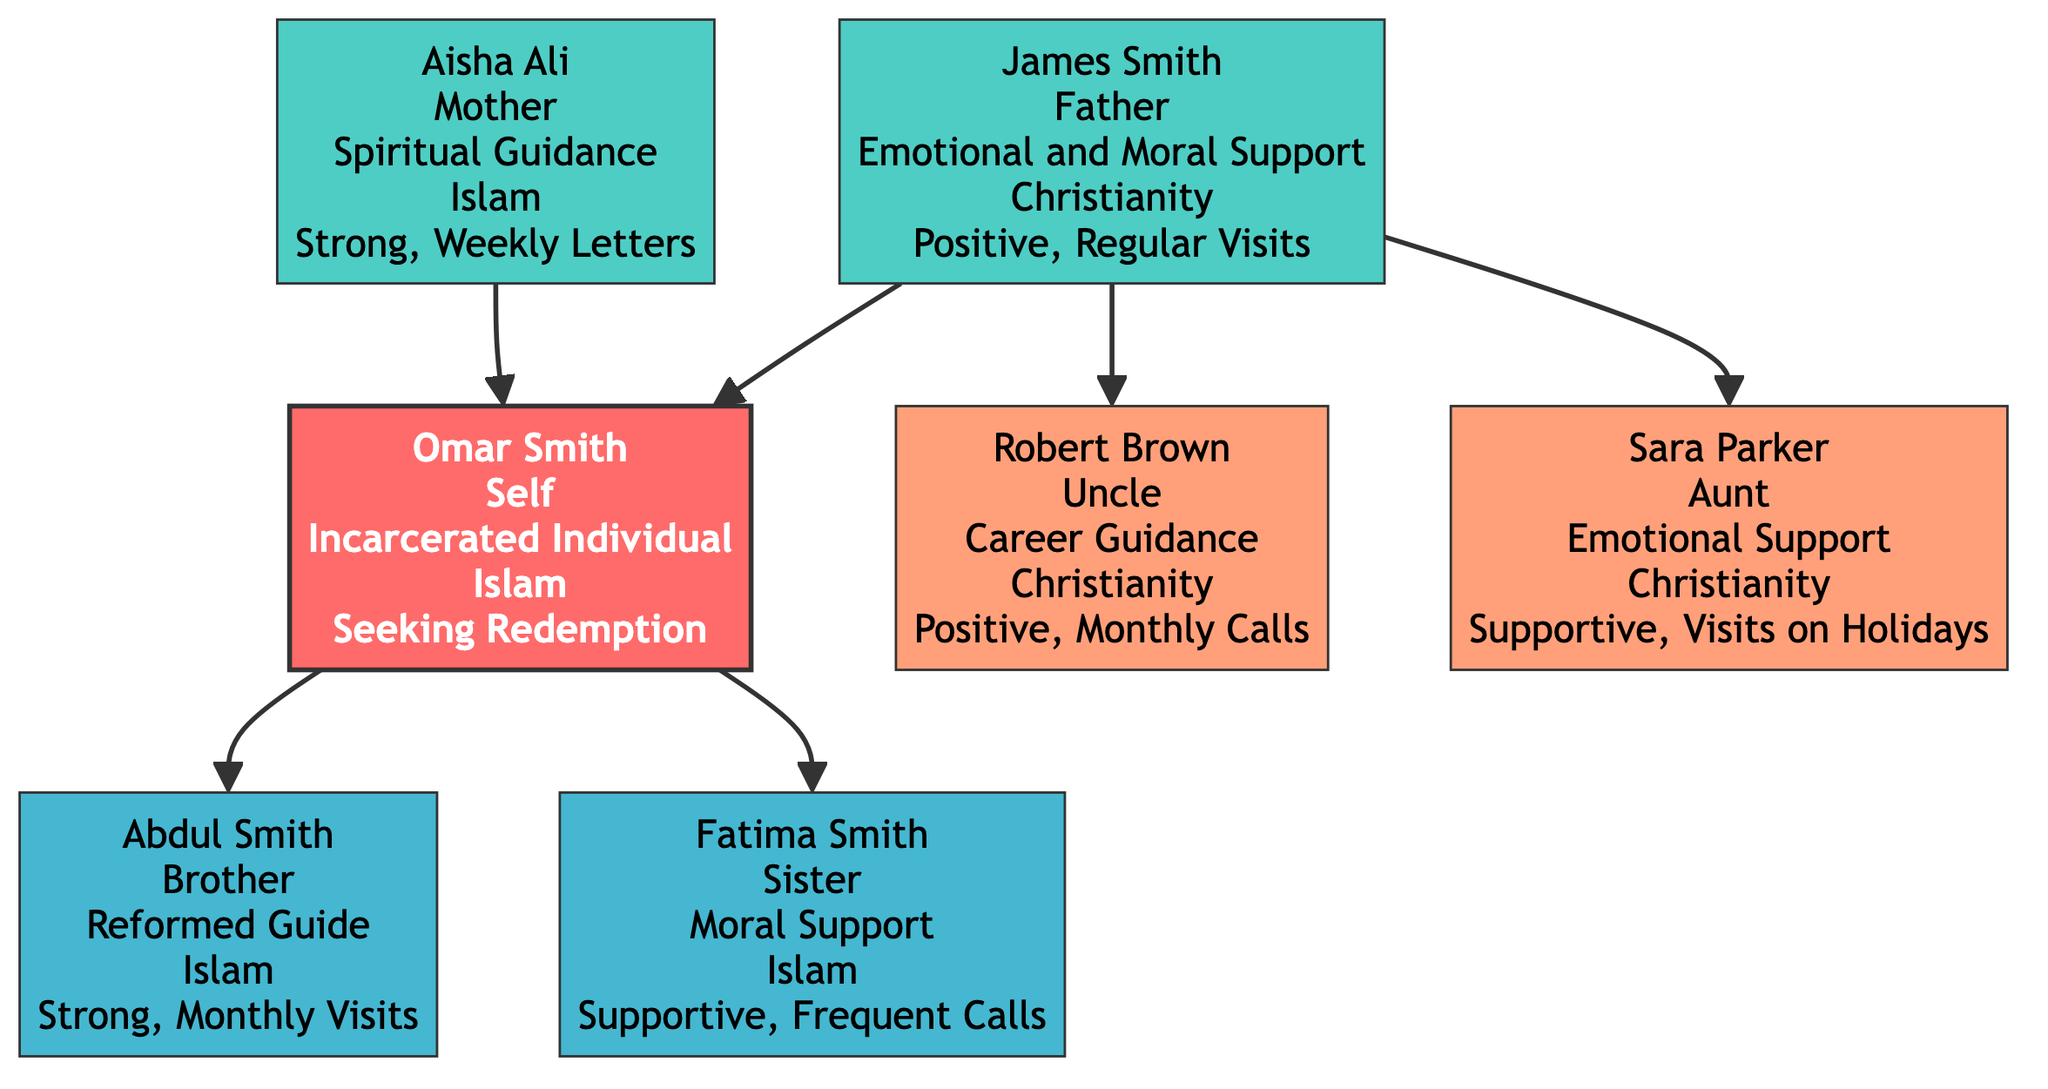What is the name of the incarcerated individual? The diagram identifies the main person as Omar Smith. This information is located at the center of the diagram, representing the main focus of the family tree.
Answer: Omar Smith How many siblings does Omar have? In the diagram, there are two siblings listed: Abdul Smith (brother) and Fatima Smith (sister). Counting both mentions confirms there are two siblings.
Answer: 2 What type of support does Omar's mother provide? The diagram specifies that Omar's mother, Aisha Ali, provides spiritual guidance. This is indicated directly next to her name in the mother section of the family tree.
Answer: Spiritual Guidance What is the relationship status between Omar and his brother? The diagram states that the relationship status between Omar and his brother Abdul Smith is "Strong, Monthly Visits." This indicates a positive interaction frequency and nature of their relationship.
Answer: Strong, Monthly Visits Which family member provides career guidance? The diagram shows that Uncle Robert Brown provides career guidance. His role and influence are explicitly stated in the extended family section.
Answer: Career Guidance What is the religion of Omar's aunt? The diagram indicates that Omar's aunt, Sara Parker, follows Christianity. This is specified under her name in the extended family section.
Answer: Christianity How often does Omar's mother write to him? The diagram mentions that Omar's mother sends weekly letters, which represents her form of communication and support during his incarceration.
Answer: Weekly Letters Which family member is identified as a reformed guide? The diagram identifies Abdul Smith, Omar's brother, as a reformed guide. This information highlights his role in supporting Omar's journey.
Answer: Reformed Guide What type of influence does Omar's father have? According to the diagram, Omar's father, James Smith, provides emotional and moral support. This reflects the nature of his relationship with Omar during incarceration.
Answer: Emotional and Moral Support 